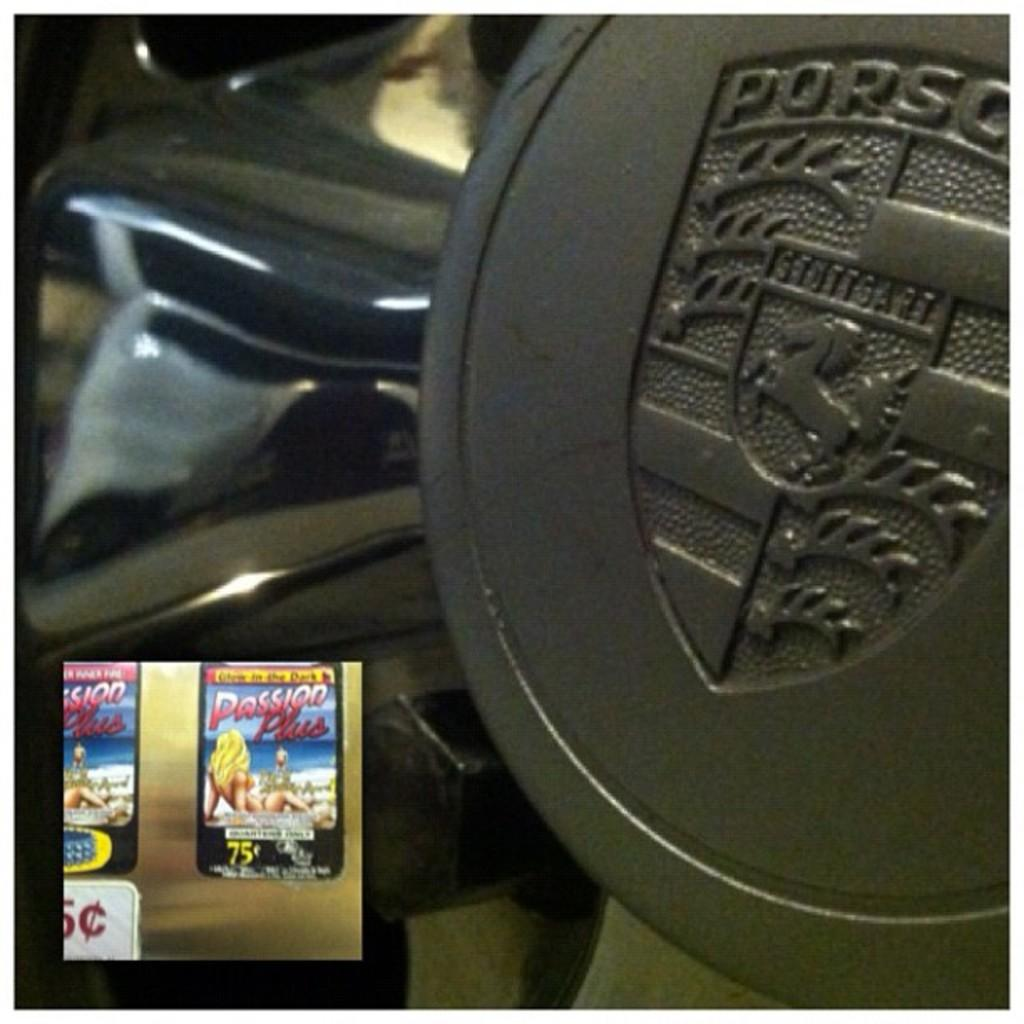What type of setting is depicted in the image? The image shows the interior view of a vehicle. What can be seen on the vehicle's interior? There is an emblem with text and a screenshot with a picture and text at the bottom in the image. How many giants are visible in the image? There are no giants present in the image. What is the position of the animal in the image? There is no animal present in the image. 